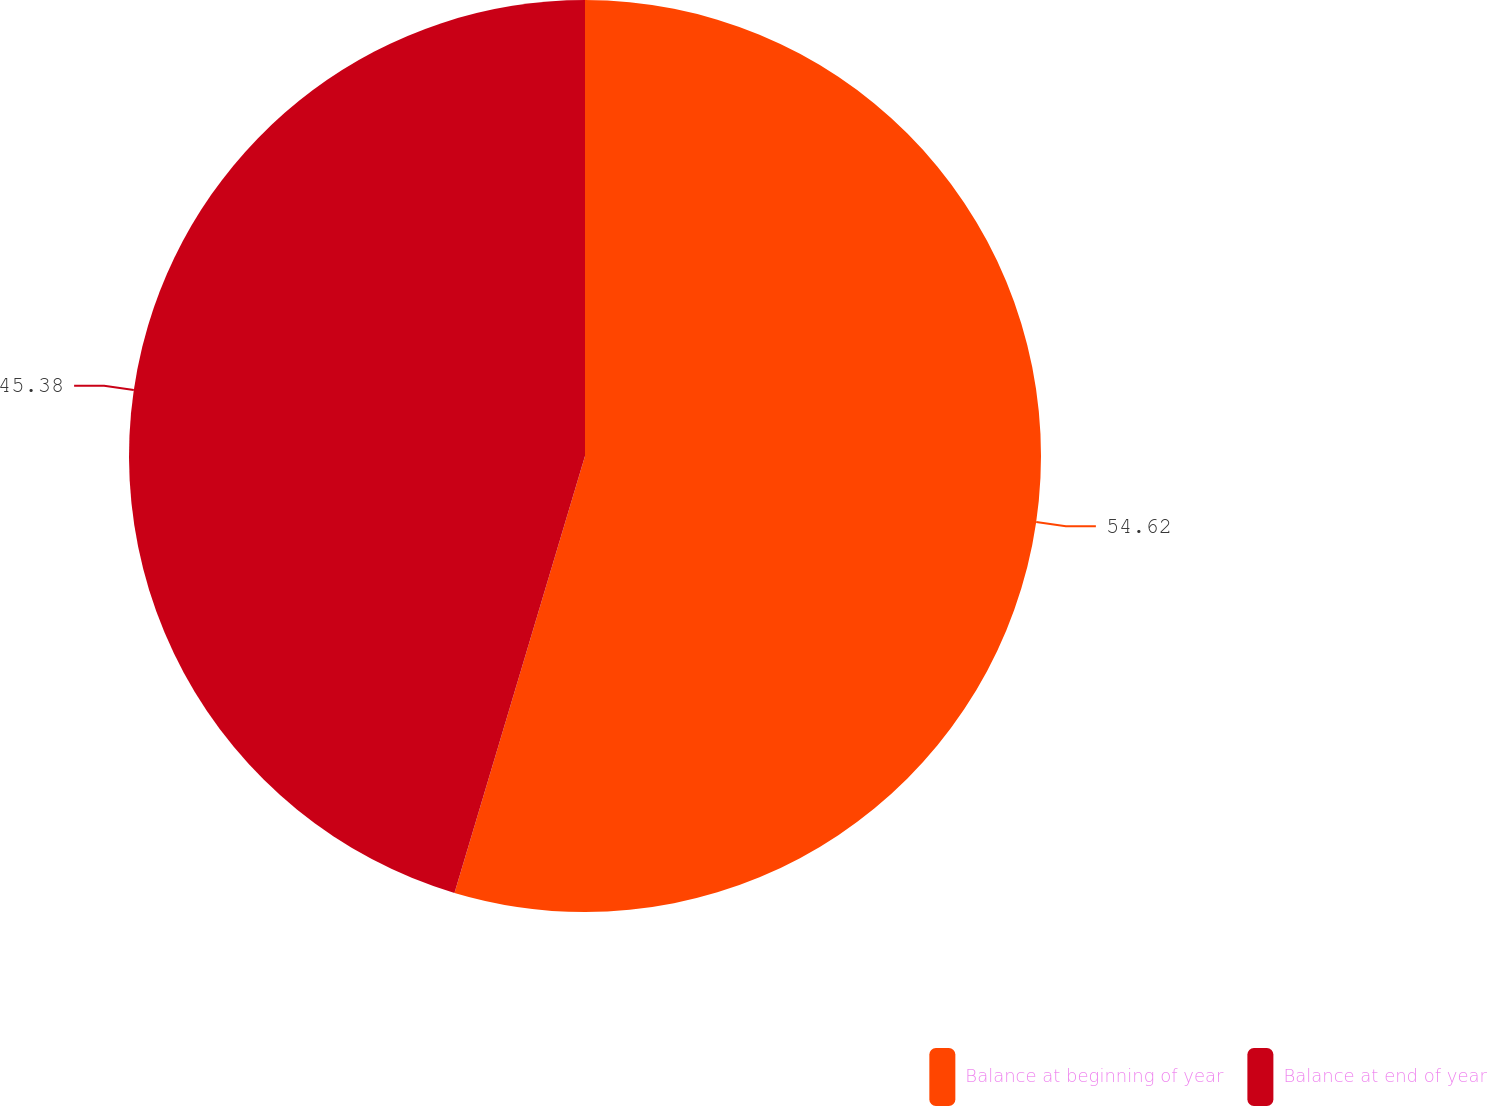<chart> <loc_0><loc_0><loc_500><loc_500><pie_chart><fcel>Balance at beginning of year<fcel>Balance at end of year<nl><fcel>54.62%<fcel>45.38%<nl></chart> 